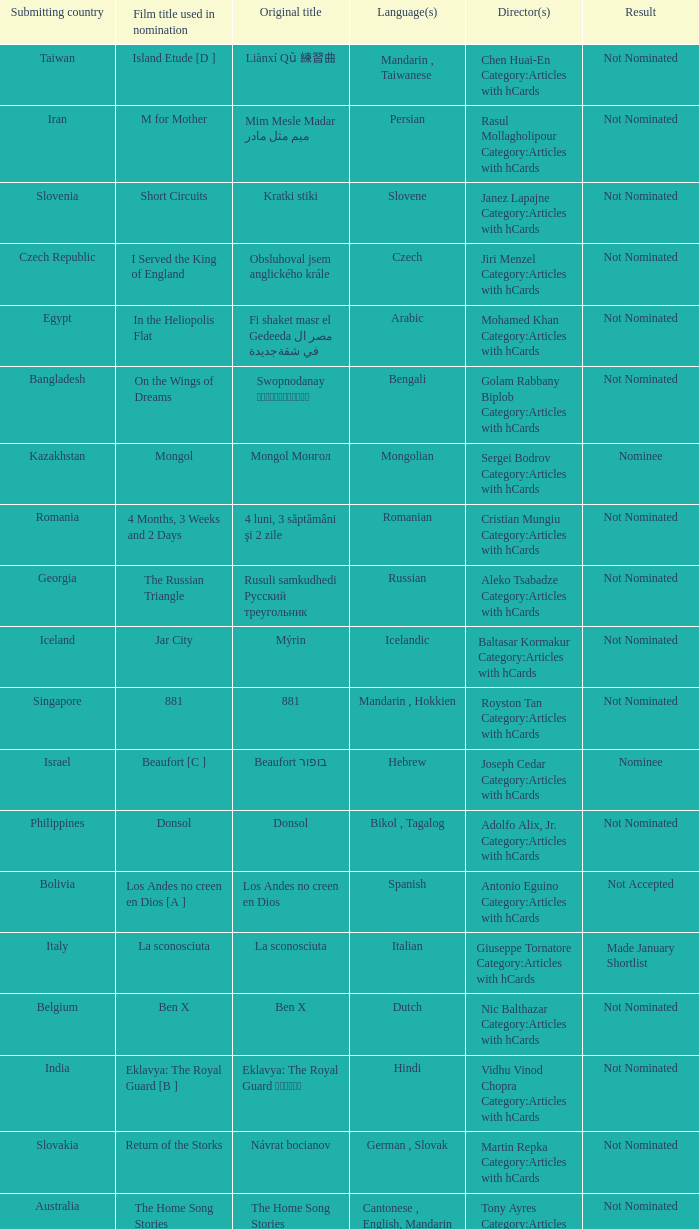What country submitted miehen työ? Finland. 